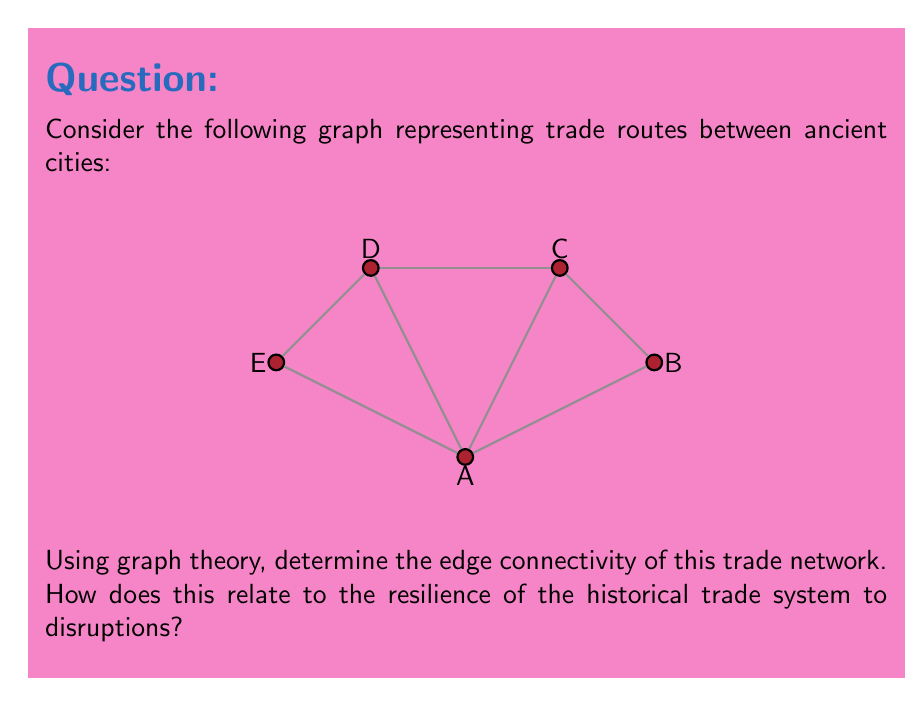Show me your answer to this math problem. To analyze the edge connectivity of this trade network, we'll follow these steps:

1) First, let's define edge connectivity. The edge connectivity of a graph, denoted as $\lambda(G)$, is the minimum number of edges that need to be removed to disconnect the graph.

2) To find $\lambda(G)$, we need to identify the minimum cut set - the smallest set of edges whose removal would disconnect the graph.

3) Let's examine potential cut sets:
   - Removing edges A-B and A-E would isolate city A, but that's 2 edges.
   - Removing A-C, A-D, and A-E would also disconnect A, but that's 3 edges.
   - Removing B-C and C-D would disconnect B from the rest, again 2 edges.
   - Any attempt to disconnect other cities also requires at least 2 edges.

4) Therefore, the minimum cut set consists of 2 edges, so $\lambda(G) = 2$.

5) Interpreting this result historically:
   - Edge connectivity represents the minimum number of trade routes that need to be disrupted to isolate a part of the network.
   - $\lambda(G) = 2$ means that at least two trade routes need to be simultaneously disrupted to isolate any city.
   - This suggests a moderately resilient trade system, as no single route failure can disconnect the network.
   - However, it's not maximally resilient, as some cities (like A and B) could be isolated by disrupting just two routes.

6) From a historical materialist perspective, this network structure implies:
   - The economic base (trade routes) significantly influences the superstructure (city connections and potential power dynamics).
   - Changes in material conditions (like the loss of trade routes) could have substantial impacts on the entire system.
   - The network's structure might reflect the historical development of trade relationships and the material constraints of geography.
Answer: $\lambda(G) = 2$, indicating moderate resilience to trade disruptions. 